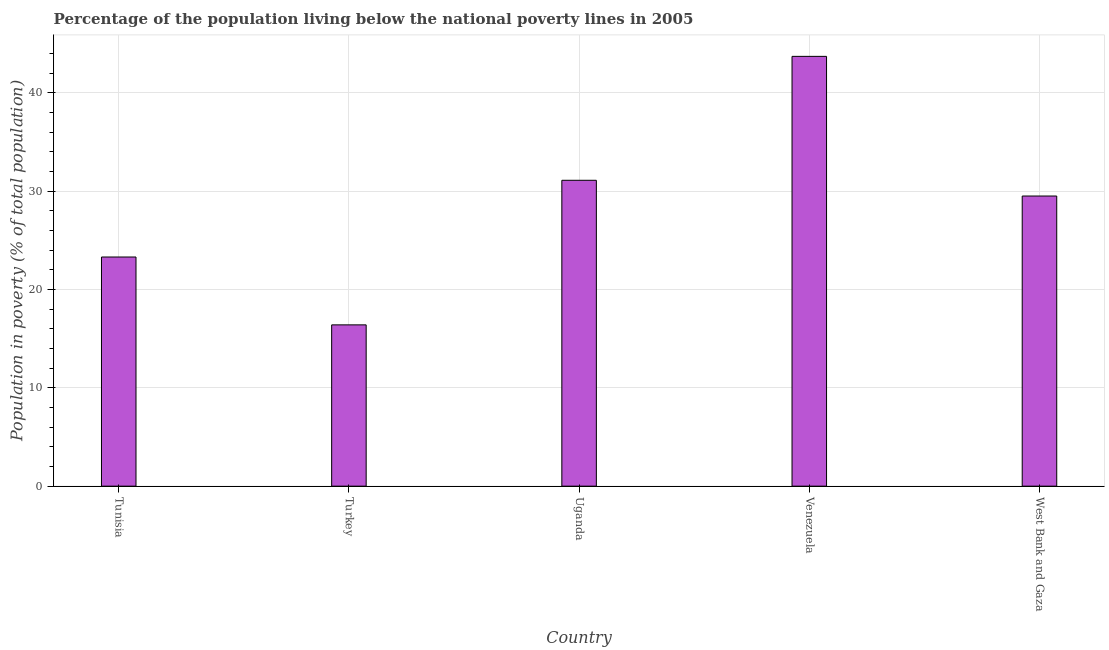Does the graph contain any zero values?
Ensure brevity in your answer.  No. What is the title of the graph?
Provide a succinct answer. Percentage of the population living below the national poverty lines in 2005. What is the label or title of the X-axis?
Ensure brevity in your answer.  Country. What is the label or title of the Y-axis?
Give a very brief answer. Population in poverty (% of total population). What is the percentage of population living below poverty line in West Bank and Gaza?
Keep it short and to the point. 29.5. Across all countries, what is the maximum percentage of population living below poverty line?
Ensure brevity in your answer.  43.7. Across all countries, what is the minimum percentage of population living below poverty line?
Your answer should be very brief. 16.4. In which country was the percentage of population living below poverty line maximum?
Provide a short and direct response. Venezuela. In which country was the percentage of population living below poverty line minimum?
Ensure brevity in your answer.  Turkey. What is the sum of the percentage of population living below poverty line?
Make the answer very short. 144. What is the difference between the percentage of population living below poverty line in Turkey and Uganda?
Make the answer very short. -14.7. What is the average percentage of population living below poverty line per country?
Your response must be concise. 28.8. What is the median percentage of population living below poverty line?
Give a very brief answer. 29.5. What is the ratio of the percentage of population living below poverty line in Turkey to that in Uganda?
Your response must be concise. 0.53. What is the difference between the highest and the lowest percentage of population living below poverty line?
Offer a very short reply. 27.3. In how many countries, is the percentage of population living below poverty line greater than the average percentage of population living below poverty line taken over all countries?
Provide a short and direct response. 3. How many bars are there?
Provide a succinct answer. 5. How many countries are there in the graph?
Offer a very short reply. 5. What is the difference between two consecutive major ticks on the Y-axis?
Your response must be concise. 10. Are the values on the major ticks of Y-axis written in scientific E-notation?
Offer a terse response. No. What is the Population in poverty (% of total population) of Tunisia?
Offer a terse response. 23.3. What is the Population in poverty (% of total population) in Uganda?
Offer a terse response. 31.1. What is the Population in poverty (% of total population) of Venezuela?
Your answer should be compact. 43.7. What is the Population in poverty (% of total population) in West Bank and Gaza?
Your response must be concise. 29.5. What is the difference between the Population in poverty (% of total population) in Tunisia and Venezuela?
Ensure brevity in your answer.  -20.4. What is the difference between the Population in poverty (% of total population) in Tunisia and West Bank and Gaza?
Your response must be concise. -6.2. What is the difference between the Population in poverty (% of total population) in Turkey and Uganda?
Make the answer very short. -14.7. What is the difference between the Population in poverty (% of total population) in Turkey and Venezuela?
Ensure brevity in your answer.  -27.3. What is the ratio of the Population in poverty (% of total population) in Tunisia to that in Turkey?
Your response must be concise. 1.42. What is the ratio of the Population in poverty (% of total population) in Tunisia to that in Uganda?
Make the answer very short. 0.75. What is the ratio of the Population in poverty (% of total population) in Tunisia to that in Venezuela?
Provide a succinct answer. 0.53. What is the ratio of the Population in poverty (% of total population) in Tunisia to that in West Bank and Gaza?
Ensure brevity in your answer.  0.79. What is the ratio of the Population in poverty (% of total population) in Turkey to that in Uganda?
Your response must be concise. 0.53. What is the ratio of the Population in poverty (% of total population) in Turkey to that in Venezuela?
Provide a succinct answer. 0.38. What is the ratio of the Population in poverty (% of total population) in Turkey to that in West Bank and Gaza?
Your response must be concise. 0.56. What is the ratio of the Population in poverty (% of total population) in Uganda to that in Venezuela?
Ensure brevity in your answer.  0.71. What is the ratio of the Population in poverty (% of total population) in Uganda to that in West Bank and Gaza?
Provide a succinct answer. 1.05. What is the ratio of the Population in poverty (% of total population) in Venezuela to that in West Bank and Gaza?
Provide a short and direct response. 1.48. 